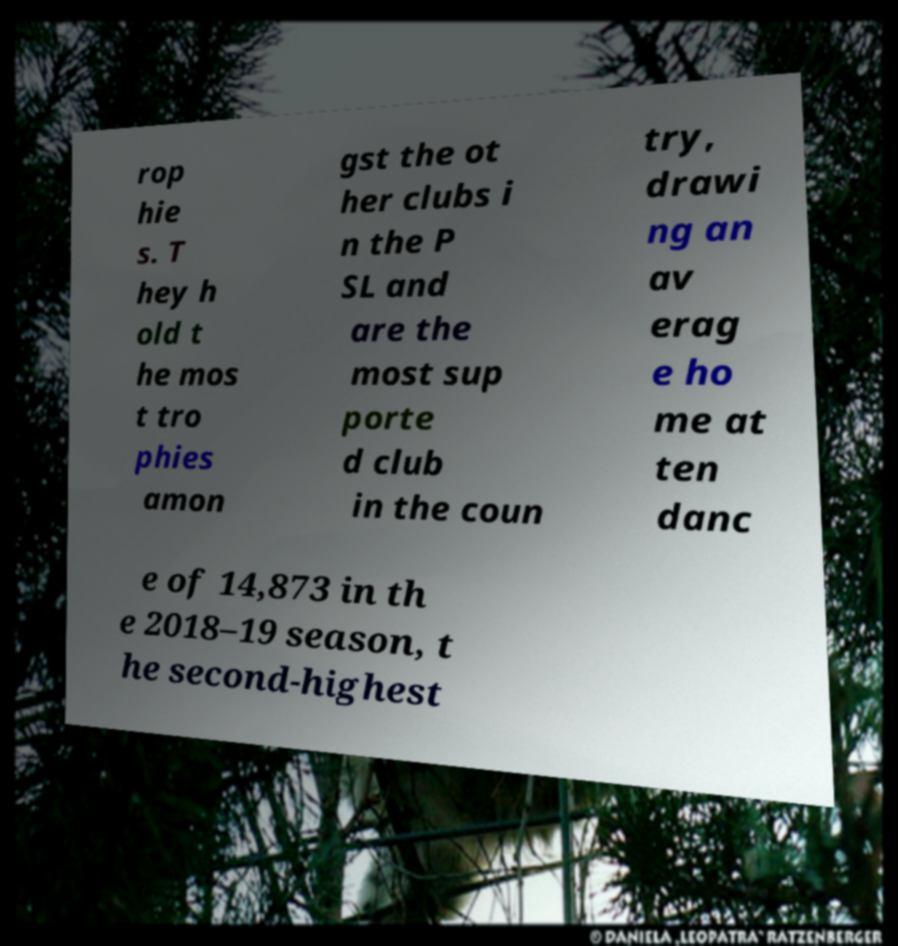Can you read and provide the text displayed in the image?This photo seems to have some interesting text. Can you extract and type it out for me? rop hie s. T hey h old t he mos t tro phies amon gst the ot her clubs i n the P SL and are the most sup porte d club in the coun try, drawi ng an av erag e ho me at ten danc e of 14,873 in th e 2018–19 season, t he second-highest 